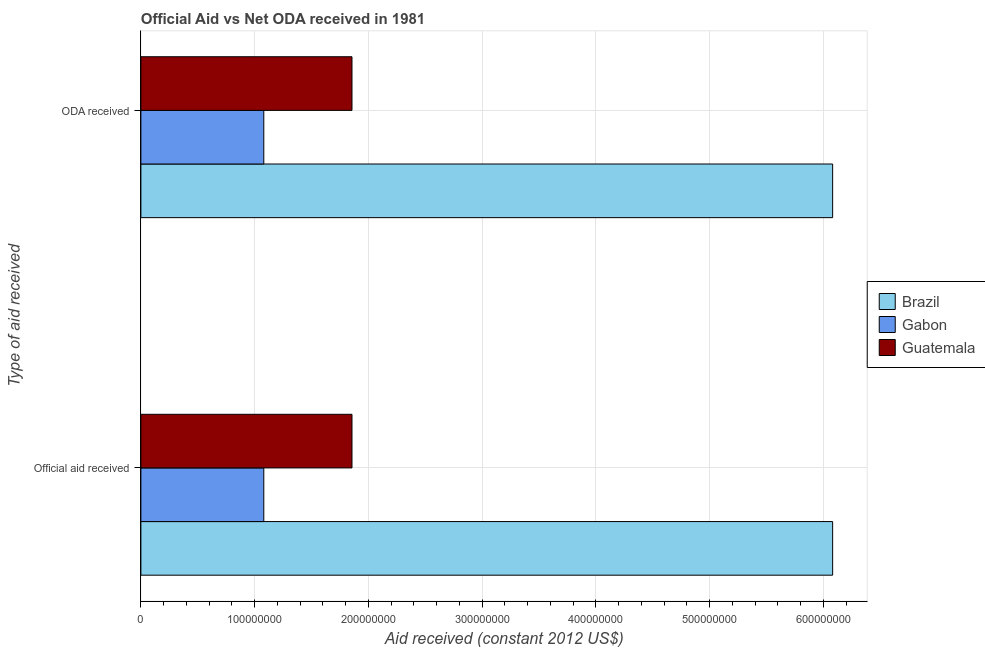Are the number of bars per tick equal to the number of legend labels?
Make the answer very short. Yes. How many bars are there on the 2nd tick from the top?
Keep it short and to the point. 3. What is the label of the 1st group of bars from the top?
Give a very brief answer. ODA received. What is the official aid received in Brazil?
Keep it short and to the point. 6.08e+08. Across all countries, what is the maximum official aid received?
Offer a terse response. 6.08e+08. Across all countries, what is the minimum oda received?
Ensure brevity in your answer.  1.08e+08. In which country was the oda received minimum?
Make the answer very short. Gabon. What is the total official aid received in the graph?
Make the answer very short. 9.02e+08. What is the difference between the oda received in Brazil and that in Guatemala?
Provide a short and direct response. 4.23e+08. What is the difference between the oda received in Guatemala and the official aid received in Brazil?
Provide a short and direct response. -4.23e+08. What is the average oda received per country?
Your response must be concise. 3.01e+08. What is the difference between the official aid received and oda received in Guatemala?
Your response must be concise. 0. What is the ratio of the oda received in Guatemala to that in Brazil?
Your answer should be compact. 0.31. Is the oda received in Gabon less than that in Guatemala?
Provide a short and direct response. Yes. What does the 1st bar from the top in Official aid received represents?
Provide a succinct answer. Guatemala. What does the 2nd bar from the bottom in ODA received represents?
Your answer should be very brief. Gabon. How many bars are there?
Offer a terse response. 6. Are all the bars in the graph horizontal?
Your answer should be very brief. Yes. How many countries are there in the graph?
Give a very brief answer. 3. Where does the legend appear in the graph?
Ensure brevity in your answer.  Center right. How many legend labels are there?
Your answer should be compact. 3. What is the title of the graph?
Offer a very short reply. Official Aid vs Net ODA received in 1981 . What is the label or title of the X-axis?
Offer a very short reply. Aid received (constant 2012 US$). What is the label or title of the Y-axis?
Give a very brief answer. Type of aid received. What is the Aid received (constant 2012 US$) in Brazil in Official aid received?
Provide a succinct answer. 6.08e+08. What is the Aid received (constant 2012 US$) in Gabon in Official aid received?
Keep it short and to the point. 1.08e+08. What is the Aid received (constant 2012 US$) of Guatemala in Official aid received?
Give a very brief answer. 1.86e+08. What is the Aid received (constant 2012 US$) of Brazil in ODA received?
Provide a succinct answer. 6.08e+08. What is the Aid received (constant 2012 US$) in Gabon in ODA received?
Offer a very short reply. 1.08e+08. What is the Aid received (constant 2012 US$) of Guatemala in ODA received?
Your response must be concise. 1.86e+08. Across all Type of aid received, what is the maximum Aid received (constant 2012 US$) of Brazil?
Provide a short and direct response. 6.08e+08. Across all Type of aid received, what is the maximum Aid received (constant 2012 US$) in Gabon?
Your response must be concise. 1.08e+08. Across all Type of aid received, what is the maximum Aid received (constant 2012 US$) in Guatemala?
Your answer should be very brief. 1.86e+08. Across all Type of aid received, what is the minimum Aid received (constant 2012 US$) of Brazil?
Give a very brief answer. 6.08e+08. Across all Type of aid received, what is the minimum Aid received (constant 2012 US$) in Gabon?
Offer a very short reply. 1.08e+08. Across all Type of aid received, what is the minimum Aid received (constant 2012 US$) of Guatemala?
Your answer should be very brief. 1.86e+08. What is the total Aid received (constant 2012 US$) in Brazil in the graph?
Provide a short and direct response. 1.22e+09. What is the total Aid received (constant 2012 US$) of Gabon in the graph?
Offer a terse response. 2.16e+08. What is the total Aid received (constant 2012 US$) in Guatemala in the graph?
Provide a short and direct response. 3.71e+08. What is the difference between the Aid received (constant 2012 US$) of Brazil in Official aid received and the Aid received (constant 2012 US$) of Gabon in ODA received?
Ensure brevity in your answer.  5.00e+08. What is the difference between the Aid received (constant 2012 US$) in Brazil in Official aid received and the Aid received (constant 2012 US$) in Guatemala in ODA received?
Your answer should be very brief. 4.23e+08. What is the difference between the Aid received (constant 2012 US$) of Gabon in Official aid received and the Aid received (constant 2012 US$) of Guatemala in ODA received?
Provide a short and direct response. -7.75e+07. What is the average Aid received (constant 2012 US$) of Brazil per Type of aid received?
Ensure brevity in your answer.  6.08e+08. What is the average Aid received (constant 2012 US$) in Gabon per Type of aid received?
Provide a succinct answer. 1.08e+08. What is the average Aid received (constant 2012 US$) of Guatemala per Type of aid received?
Provide a short and direct response. 1.86e+08. What is the difference between the Aid received (constant 2012 US$) in Brazil and Aid received (constant 2012 US$) in Gabon in Official aid received?
Provide a succinct answer. 5.00e+08. What is the difference between the Aid received (constant 2012 US$) of Brazil and Aid received (constant 2012 US$) of Guatemala in Official aid received?
Keep it short and to the point. 4.23e+08. What is the difference between the Aid received (constant 2012 US$) in Gabon and Aid received (constant 2012 US$) in Guatemala in Official aid received?
Offer a very short reply. -7.75e+07. What is the difference between the Aid received (constant 2012 US$) of Brazil and Aid received (constant 2012 US$) of Gabon in ODA received?
Offer a very short reply. 5.00e+08. What is the difference between the Aid received (constant 2012 US$) in Brazil and Aid received (constant 2012 US$) in Guatemala in ODA received?
Your answer should be very brief. 4.23e+08. What is the difference between the Aid received (constant 2012 US$) of Gabon and Aid received (constant 2012 US$) of Guatemala in ODA received?
Offer a very short reply. -7.75e+07. What is the ratio of the Aid received (constant 2012 US$) in Brazil in Official aid received to that in ODA received?
Offer a terse response. 1. What is the ratio of the Aid received (constant 2012 US$) in Gabon in Official aid received to that in ODA received?
Ensure brevity in your answer.  1. What is the difference between the highest and the second highest Aid received (constant 2012 US$) in Guatemala?
Provide a short and direct response. 0. What is the difference between the highest and the lowest Aid received (constant 2012 US$) in Gabon?
Keep it short and to the point. 0. What is the difference between the highest and the lowest Aid received (constant 2012 US$) in Guatemala?
Keep it short and to the point. 0. 